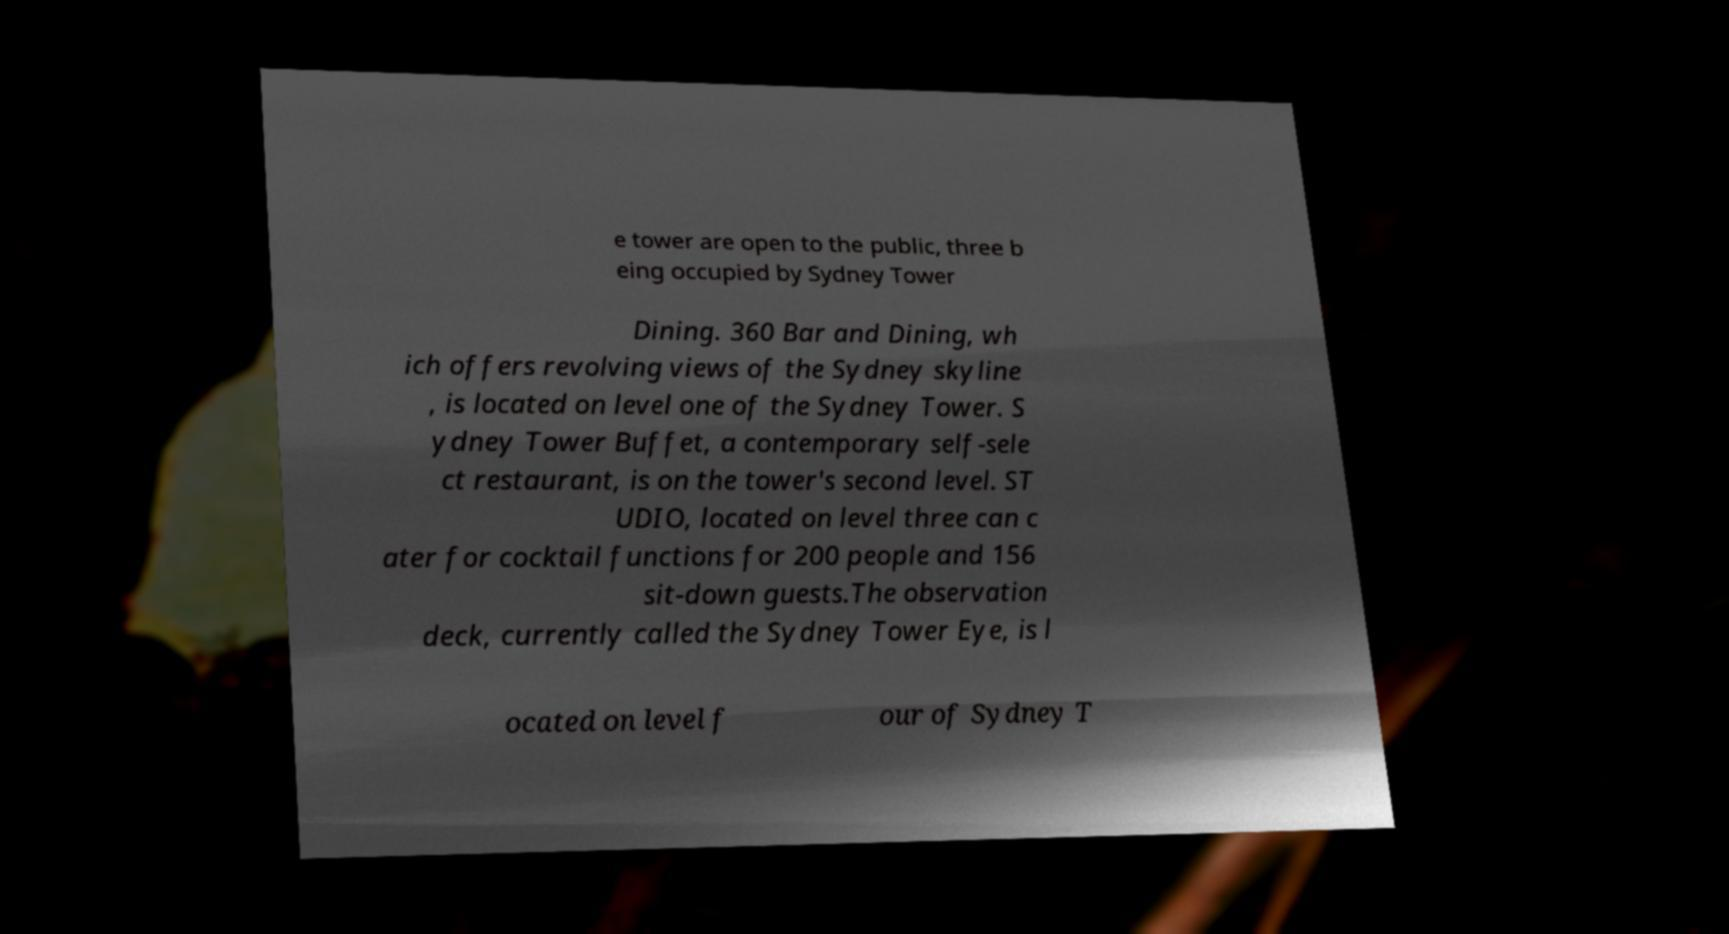I need the written content from this picture converted into text. Can you do that? e tower are open to the public, three b eing occupied by Sydney Tower Dining. 360 Bar and Dining, wh ich offers revolving views of the Sydney skyline , is located on level one of the Sydney Tower. S ydney Tower Buffet, a contemporary self-sele ct restaurant, is on the tower's second level. ST UDIO, located on level three can c ater for cocktail functions for 200 people and 156 sit-down guests.The observation deck, currently called the Sydney Tower Eye, is l ocated on level f our of Sydney T 